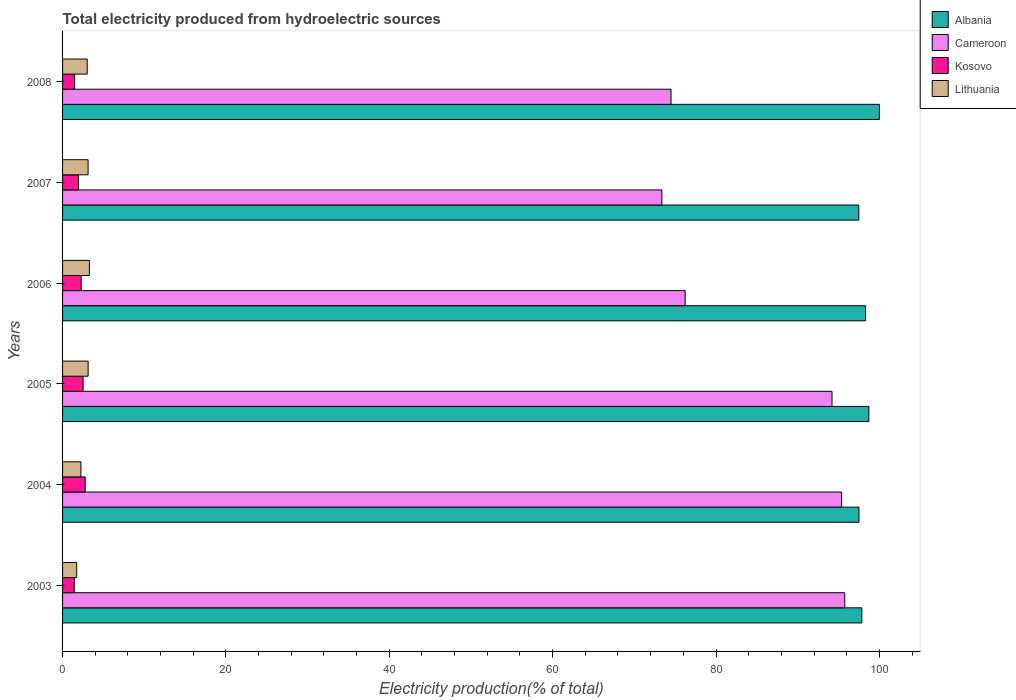How many different coloured bars are there?
Your response must be concise. 4. Are the number of bars per tick equal to the number of legend labels?
Provide a succinct answer. Yes. What is the label of the 1st group of bars from the top?
Ensure brevity in your answer.  2008. In how many cases, is the number of bars for a given year not equal to the number of legend labels?
Offer a terse response. 0. What is the total electricity produced in Lithuania in 2008?
Keep it short and to the point. 3.02. Across all years, what is the maximum total electricity produced in Lithuania?
Offer a very short reply. 3.29. Across all years, what is the minimum total electricity produced in Kosovo?
Your response must be concise. 1.43. In which year was the total electricity produced in Cameroon minimum?
Your response must be concise. 2007. What is the total total electricity produced in Lithuania in the graph?
Provide a short and direct response. 16.53. What is the difference between the total electricity produced in Lithuania in 2003 and that in 2007?
Your response must be concise. -1.4. What is the difference between the total electricity produced in Albania in 2006 and the total electricity produced in Lithuania in 2008?
Provide a succinct answer. 95.3. What is the average total electricity produced in Albania per year?
Provide a short and direct response. 98.31. In the year 2003, what is the difference between the total electricity produced in Kosovo and total electricity produced in Cameroon?
Keep it short and to the point. -94.33. In how many years, is the total electricity produced in Albania greater than 48 %?
Ensure brevity in your answer.  6. What is the ratio of the total electricity produced in Lithuania in 2004 to that in 2008?
Your response must be concise. 0.74. Is the difference between the total electricity produced in Kosovo in 2003 and 2006 greater than the difference between the total electricity produced in Cameroon in 2003 and 2006?
Offer a very short reply. No. What is the difference between the highest and the second highest total electricity produced in Cameroon?
Your response must be concise. 0.39. What is the difference between the highest and the lowest total electricity produced in Kosovo?
Provide a succinct answer. 1.34. In how many years, is the total electricity produced in Kosovo greater than the average total electricity produced in Kosovo taken over all years?
Provide a short and direct response. 3. Is the sum of the total electricity produced in Albania in 2004 and 2005 greater than the maximum total electricity produced in Cameroon across all years?
Provide a short and direct response. Yes. What does the 2nd bar from the top in 2008 represents?
Provide a short and direct response. Kosovo. What does the 2nd bar from the bottom in 2008 represents?
Your response must be concise. Cameroon. How many bars are there?
Make the answer very short. 24. Are all the bars in the graph horizontal?
Your response must be concise. Yes. Where does the legend appear in the graph?
Keep it short and to the point. Top right. How many legend labels are there?
Make the answer very short. 4. How are the legend labels stacked?
Ensure brevity in your answer.  Vertical. What is the title of the graph?
Your response must be concise. Total electricity produced from hydroelectric sources. Does "Central Europe" appear as one of the legend labels in the graph?
Your answer should be compact. No. What is the label or title of the Y-axis?
Provide a short and direct response. Years. What is the Electricity production(% of total) in Albania in 2003?
Provide a succinct answer. 97.86. What is the Electricity production(% of total) of Cameroon in 2003?
Offer a very short reply. 95.77. What is the Electricity production(% of total) in Kosovo in 2003?
Give a very brief answer. 1.43. What is the Electricity production(% of total) in Lithuania in 2003?
Provide a short and direct response. 1.73. What is the Electricity production(% of total) in Albania in 2004?
Your answer should be compact. 97.5. What is the Electricity production(% of total) in Cameroon in 2004?
Keep it short and to the point. 95.38. What is the Electricity production(% of total) of Kosovo in 2004?
Your response must be concise. 2.77. What is the Electricity production(% of total) in Lithuania in 2004?
Ensure brevity in your answer.  2.25. What is the Electricity production(% of total) in Albania in 2005?
Offer a terse response. 98.71. What is the Electricity production(% of total) in Cameroon in 2005?
Your answer should be compact. 94.21. What is the Electricity production(% of total) of Kosovo in 2005?
Offer a terse response. 2.51. What is the Electricity production(% of total) in Lithuania in 2005?
Ensure brevity in your answer.  3.13. What is the Electricity production(% of total) of Albania in 2006?
Your answer should be very brief. 98.32. What is the Electricity production(% of total) of Cameroon in 2006?
Make the answer very short. 76.22. What is the Electricity production(% of total) in Kosovo in 2006?
Keep it short and to the point. 2.28. What is the Electricity production(% of total) in Lithuania in 2006?
Keep it short and to the point. 3.29. What is the Electricity production(% of total) of Albania in 2007?
Provide a short and direct response. 97.48. What is the Electricity production(% of total) in Cameroon in 2007?
Give a very brief answer. 73.37. What is the Electricity production(% of total) of Kosovo in 2007?
Your answer should be compact. 1.94. What is the Electricity production(% of total) in Lithuania in 2007?
Provide a short and direct response. 3.13. What is the Electricity production(% of total) in Albania in 2008?
Make the answer very short. 100. What is the Electricity production(% of total) of Cameroon in 2008?
Offer a terse response. 74.49. What is the Electricity production(% of total) of Kosovo in 2008?
Provide a short and direct response. 1.47. What is the Electricity production(% of total) in Lithuania in 2008?
Offer a terse response. 3.02. Across all years, what is the maximum Electricity production(% of total) in Cameroon?
Make the answer very short. 95.77. Across all years, what is the maximum Electricity production(% of total) in Kosovo?
Ensure brevity in your answer.  2.77. Across all years, what is the maximum Electricity production(% of total) of Lithuania?
Provide a short and direct response. 3.29. Across all years, what is the minimum Electricity production(% of total) in Albania?
Make the answer very short. 97.48. Across all years, what is the minimum Electricity production(% of total) of Cameroon?
Your answer should be very brief. 73.37. Across all years, what is the minimum Electricity production(% of total) of Kosovo?
Your response must be concise. 1.43. Across all years, what is the minimum Electricity production(% of total) in Lithuania?
Your answer should be compact. 1.73. What is the total Electricity production(% of total) of Albania in the graph?
Offer a terse response. 589.87. What is the total Electricity production(% of total) in Cameroon in the graph?
Provide a succinct answer. 509.44. What is the total Electricity production(% of total) of Kosovo in the graph?
Your answer should be very brief. 12.41. What is the total Electricity production(% of total) in Lithuania in the graph?
Your answer should be very brief. 16.53. What is the difference between the Electricity production(% of total) of Albania in 2003 and that in 2004?
Provide a short and direct response. 0.35. What is the difference between the Electricity production(% of total) in Cameroon in 2003 and that in 2004?
Your answer should be very brief. 0.39. What is the difference between the Electricity production(% of total) of Kosovo in 2003 and that in 2004?
Make the answer very short. -1.34. What is the difference between the Electricity production(% of total) in Lithuania in 2003 and that in 2004?
Provide a succinct answer. -0.52. What is the difference between the Electricity production(% of total) in Albania in 2003 and that in 2005?
Provide a succinct answer. -0.86. What is the difference between the Electricity production(% of total) in Cameroon in 2003 and that in 2005?
Your answer should be very brief. 1.56. What is the difference between the Electricity production(% of total) of Kosovo in 2003 and that in 2005?
Provide a short and direct response. -1.08. What is the difference between the Electricity production(% of total) in Lithuania in 2003 and that in 2005?
Your answer should be very brief. -1.4. What is the difference between the Electricity production(% of total) in Albania in 2003 and that in 2006?
Make the answer very short. -0.46. What is the difference between the Electricity production(% of total) in Cameroon in 2003 and that in 2006?
Your answer should be very brief. 19.54. What is the difference between the Electricity production(% of total) in Kosovo in 2003 and that in 2006?
Offer a terse response. -0.85. What is the difference between the Electricity production(% of total) in Lithuania in 2003 and that in 2006?
Provide a short and direct response. -1.56. What is the difference between the Electricity production(% of total) of Albania in 2003 and that in 2007?
Your response must be concise. 0.37. What is the difference between the Electricity production(% of total) of Cameroon in 2003 and that in 2007?
Ensure brevity in your answer.  22.39. What is the difference between the Electricity production(% of total) of Kosovo in 2003 and that in 2007?
Give a very brief answer. -0.51. What is the difference between the Electricity production(% of total) of Lithuania in 2003 and that in 2007?
Your answer should be compact. -1.4. What is the difference between the Electricity production(% of total) in Albania in 2003 and that in 2008?
Offer a terse response. -2.14. What is the difference between the Electricity production(% of total) of Cameroon in 2003 and that in 2008?
Ensure brevity in your answer.  21.27. What is the difference between the Electricity production(% of total) in Kosovo in 2003 and that in 2008?
Your answer should be compact. -0.04. What is the difference between the Electricity production(% of total) of Lithuania in 2003 and that in 2008?
Give a very brief answer. -1.29. What is the difference between the Electricity production(% of total) of Albania in 2004 and that in 2005?
Keep it short and to the point. -1.21. What is the difference between the Electricity production(% of total) of Cameroon in 2004 and that in 2005?
Offer a terse response. 1.17. What is the difference between the Electricity production(% of total) of Kosovo in 2004 and that in 2005?
Make the answer very short. 0.26. What is the difference between the Electricity production(% of total) in Lithuania in 2004 and that in 2005?
Offer a terse response. -0.88. What is the difference between the Electricity production(% of total) in Albania in 2004 and that in 2006?
Ensure brevity in your answer.  -0.81. What is the difference between the Electricity production(% of total) in Cameroon in 2004 and that in 2006?
Your answer should be compact. 19.15. What is the difference between the Electricity production(% of total) of Kosovo in 2004 and that in 2006?
Keep it short and to the point. 0.49. What is the difference between the Electricity production(% of total) of Lithuania in 2004 and that in 2006?
Provide a short and direct response. -1.04. What is the difference between the Electricity production(% of total) in Albania in 2004 and that in 2007?
Provide a succinct answer. 0.02. What is the difference between the Electricity production(% of total) in Cameroon in 2004 and that in 2007?
Keep it short and to the point. 22. What is the difference between the Electricity production(% of total) of Kosovo in 2004 and that in 2007?
Provide a succinct answer. 0.82. What is the difference between the Electricity production(% of total) of Lithuania in 2004 and that in 2007?
Your answer should be very brief. -0.88. What is the difference between the Electricity production(% of total) in Albania in 2004 and that in 2008?
Your response must be concise. -2.5. What is the difference between the Electricity production(% of total) of Cameroon in 2004 and that in 2008?
Offer a terse response. 20.88. What is the difference between the Electricity production(% of total) of Kosovo in 2004 and that in 2008?
Make the answer very short. 1.3. What is the difference between the Electricity production(% of total) of Lithuania in 2004 and that in 2008?
Offer a very short reply. -0.77. What is the difference between the Electricity production(% of total) of Albania in 2005 and that in 2006?
Your answer should be compact. 0.4. What is the difference between the Electricity production(% of total) in Cameroon in 2005 and that in 2006?
Provide a short and direct response. 17.98. What is the difference between the Electricity production(% of total) in Kosovo in 2005 and that in 2006?
Provide a short and direct response. 0.23. What is the difference between the Electricity production(% of total) of Lithuania in 2005 and that in 2006?
Your answer should be compact. -0.16. What is the difference between the Electricity production(% of total) in Albania in 2005 and that in 2007?
Keep it short and to the point. 1.23. What is the difference between the Electricity production(% of total) in Cameroon in 2005 and that in 2007?
Provide a short and direct response. 20.83. What is the difference between the Electricity production(% of total) in Kosovo in 2005 and that in 2007?
Your answer should be compact. 0.57. What is the difference between the Electricity production(% of total) in Lithuania in 2005 and that in 2007?
Give a very brief answer. 0. What is the difference between the Electricity production(% of total) of Albania in 2005 and that in 2008?
Provide a short and direct response. -1.29. What is the difference between the Electricity production(% of total) in Cameroon in 2005 and that in 2008?
Ensure brevity in your answer.  19.71. What is the difference between the Electricity production(% of total) of Kosovo in 2005 and that in 2008?
Provide a short and direct response. 1.04. What is the difference between the Electricity production(% of total) in Lithuania in 2005 and that in 2008?
Offer a very short reply. 0.11. What is the difference between the Electricity production(% of total) in Albania in 2006 and that in 2007?
Keep it short and to the point. 0.83. What is the difference between the Electricity production(% of total) in Cameroon in 2006 and that in 2007?
Your answer should be very brief. 2.85. What is the difference between the Electricity production(% of total) in Kosovo in 2006 and that in 2007?
Your answer should be very brief. 0.33. What is the difference between the Electricity production(% of total) in Lithuania in 2006 and that in 2007?
Keep it short and to the point. 0.16. What is the difference between the Electricity production(% of total) in Albania in 2006 and that in 2008?
Make the answer very short. -1.68. What is the difference between the Electricity production(% of total) of Cameroon in 2006 and that in 2008?
Provide a succinct answer. 1.73. What is the difference between the Electricity production(% of total) in Kosovo in 2006 and that in 2008?
Make the answer very short. 0.81. What is the difference between the Electricity production(% of total) of Lithuania in 2006 and that in 2008?
Give a very brief answer. 0.27. What is the difference between the Electricity production(% of total) of Albania in 2007 and that in 2008?
Provide a short and direct response. -2.52. What is the difference between the Electricity production(% of total) in Cameroon in 2007 and that in 2008?
Provide a succinct answer. -1.12. What is the difference between the Electricity production(% of total) of Kosovo in 2007 and that in 2008?
Your response must be concise. 0.47. What is the difference between the Electricity production(% of total) of Lithuania in 2007 and that in 2008?
Your answer should be very brief. 0.11. What is the difference between the Electricity production(% of total) in Albania in 2003 and the Electricity production(% of total) in Cameroon in 2004?
Your answer should be compact. 2.48. What is the difference between the Electricity production(% of total) of Albania in 2003 and the Electricity production(% of total) of Kosovo in 2004?
Provide a succinct answer. 95.09. What is the difference between the Electricity production(% of total) of Albania in 2003 and the Electricity production(% of total) of Lithuania in 2004?
Provide a succinct answer. 95.61. What is the difference between the Electricity production(% of total) in Cameroon in 2003 and the Electricity production(% of total) in Kosovo in 2004?
Ensure brevity in your answer.  93. What is the difference between the Electricity production(% of total) in Cameroon in 2003 and the Electricity production(% of total) in Lithuania in 2004?
Offer a very short reply. 93.52. What is the difference between the Electricity production(% of total) in Kosovo in 2003 and the Electricity production(% of total) in Lithuania in 2004?
Ensure brevity in your answer.  -0.81. What is the difference between the Electricity production(% of total) in Albania in 2003 and the Electricity production(% of total) in Cameroon in 2005?
Provide a succinct answer. 3.65. What is the difference between the Electricity production(% of total) in Albania in 2003 and the Electricity production(% of total) in Kosovo in 2005?
Keep it short and to the point. 95.34. What is the difference between the Electricity production(% of total) of Albania in 2003 and the Electricity production(% of total) of Lithuania in 2005?
Provide a succinct answer. 94.73. What is the difference between the Electricity production(% of total) in Cameroon in 2003 and the Electricity production(% of total) in Kosovo in 2005?
Give a very brief answer. 93.25. What is the difference between the Electricity production(% of total) of Cameroon in 2003 and the Electricity production(% of total) of Lithuania in 2005?
Keep it short and to the point. 92.64. What is the difference between the Electricity production(% of total) in Kosovo in 2003 and the Electricity production(% of total) in Lithuania in 2005?
Your response must be concise. -1.7. What is the difference between the Electricity production(% of total) in Albania in 2003 and the Electricity production(% of total) in Cameroon in 2006?
Ensure brevity in your answer.  21.63. What is the difference between the Electricity production(% of total) of Albania in 2003 and the Electricity production(% of total) of Kosovo in 2006?
Your answer should be very brief. 95.58. What is the difference between the Electricity production(% of total) of Albania in 2003 and the Electricity production(% of total) of Lithuania in 2006?
Provide a succinct answer. 94.57. What is the difference between the Electricity production(% of total) of Cameroon in 2003 and the Electricity production(% of total) of Kosovo in 2006?
Offer a terse response. 93.49. What is the difference between the Electricity production(% of total) in Cameroon in 2003 and the Electricity production(% of total) in Lithuania in 2006?
Your answer should be compact. 92.48. What is the difference between the Electricity production(% of total) in Kosovo in 2003 and the Electricity production(% of total) in Lithuania in 2006?
Your response must be concise. -1.85. What is the difference between the Electricity production(% of total) in Albania in 2003 and the Electricity production(% of total) in Cameroon in 2007?
Your answer should be very brief. 24.48. What is the difference between the Electricity production(% of total) in Albania in 2003 and the Electricity production(% of total) in Kosovo in 2007?
Ensure brevity in your answer.  95.91. What is the difference between the Electricity production(% of total) of Albania in 2003 and the Electricity production(% of total) of Lithuania in 2007?
Give a very brief answer. 94.73. What is the difference between the Electricity production(% of total) of Cameroon in 2003 and the Electricity production(% of total) of Kosovo in 2007?
Offer a terse response. 93.82. What is the difference between the Electricity production(% of total) of Cameroon in 2003 and the Electricity production(% of total) of Lithuania in 2007?
Offer a terse response. 92.64. What is the difference between the Electricity production(% of total) of Kosovo in 2003 and the Electricity production(% of total) of Lithuania in 2007?
Make the answer very short. -1.69. What is the difference between the Electricity production(% of total) in Albania in 2003 and the Electricity production(% of total) in Cameroon in 2008?
Your answer should be compact. 23.36. What is the difference between the Electricity production(% of total) of Albania in 2003 and the Electricity production(% of total) of Kosovo in 2008?
Ensure brevity in your answer.  96.38. What is the difference between the Electricity production(% of total) of Albania in 2003 and the Electricity production(% of total) of Lithuania in 2008?
Make the answer very short. 94.84. What is the difference between the Electricity production(% of total) of Cameroon in 2003 and the Electricity production(% of total) of Kosovo in 2008?
Provide a short and direct response. 94.29. What is the difference between the Electricity production(% of total) of Cameroon in 2003 and the Electricity production(% of total) of Lithuania in 2008?
Offer a very short reply. 92.75. What is the difference between the Electricity production(% of total) in Kosovo in 2003 and the Electricity production(% of total) in Lithuania in 2008?
Your answer should be compact. -1.58. What is the difference between the Electricity production(% of total) of Albania in 2004 and the Electricity production(% of total) of Cameroon in 2005?
Keep it short and to the point. 3.3. What is the difference between the Electricity production(% of total) of Albania in 2004 and the Electricity production(% of total) of Kosovo in 2005?
Provide a succinct answer. 94.99. What is the difference between the Electricity production(% of total) in Albania in 2004 and the Electricity production(% of total) in Lithuania in 2005?
Your response must be concise. 94.37. What is the difference between the Electricity production(% of total) in Cameroon in 2004 and the Electricity production(% of total) in Kosovo in 2005?
Give a very brief answer. 92.86. What is the difference between the Electricity production(% of total) in Cameroon in 2004 and the Electricity production(% of total) in Lithuania in 2005?
Ensure brevity in your answer.  92.25. What is the difference between the Electricity production(% of total) in Kosovo in 2004 and the Electricity production(% of total) in Lithuania in 2005?
Provide a short and direct response. -0.36. What is the difference between the Electricity production(% of total) in Albania in 2004 and the Electricity production(% of total) in Cameroon in 2006?
Offer a very short reply. 21.28. What is the difference between the Electricity production(% of total) of Albania in 2004 and the Electricity production(% of total) of Kosovo in 2006?
Your answer should be very brief. 95.22. What is the difference between the Electricity production(% of total) in Albania in 2004 and the Electricity production(% of total) in Lithuania in 2006?
Provide a succinct answer. 94.22. What is the difference between the Electricity production(% of total) in Cameroon in 2004 and the Electricity production(% of total) in Kosovo in 2006?
Offer a very short reply. 93.1. What is the difference between the Electricity production(% of total) of Cameroon in 2004 and the Electricity production(% of total) of Lithuania in 2006?
Give a very brief answer. 92.09. What is the difference between the Electricity production(% of total) of Kosovo in 2004 and the Electricity production(% of total) of Lithuania in 2006?
Provide a short and direct response. -0.52. What is the difference between the Electricity production(% of total) in Albania in 2004 and the Electricity production(% of total) in Cameroon in 2007?
Make the answer very short. 24.13. What is the difference between the Electricity production(% of total) in Albania in 2004 and the Electricity production(% of total) in Kosovo in 2007?
Offer a terse response. 95.56. What is the difference between the Electricity production(% of total) in Albania in 2004 and the Electricity production(% of total) in Lithuania in 2007?
Your response must be concise. 94.38. What is the difference between the Electricity production(% of total) in Cameroon in 2004 and the Electricity production(% of total) in Kosovo in 2007?
Offer a terse response. 93.43. What is the difference between the Electricity production(% of total) in Cameroon in 2004 and the Electricity production(% of total) in Lithuania in 2007?
Keep it short and to the point. 92.25. What is the difference between the Electricity production(% of total) in Kosovo in 2004 and the Electricity production(% of total) in Lithuania in 2007?
Make the answer very short. -0.36. What is the difference between the Electricity production(% of total) of Albania in 2004 and the Electricity production(% of total) of Cameroon in 2008?
Provide a succinct answer. 23.01. What is the difference between the Electricity production(% of total) of Albania in 2004 and the Electricity production(% of total) of Kosovo in 2008?
Keep it short and to the point. 96.03. What is the difference between the Electricity production(% of total) of Albania in 2004 and the Electricity production(% of total) of Lithuania in 2008?
Offer a very short reply. 94.49. What is the difference between the Electricity production(% of total) of Cameroon in 2004 and the Electricity production(% of total) of Kosovo in 2008?
Your answer should be very brief. 93.9. What is the difference between the Electricity production(% of total) in Cameroon in 2004 and the Electricity production(% of total) in Lithuania in 2008?
Your answer should be compact. 92.36. What is the difference between the Electricity production(% of total) in Kosovo in 2004 and the Electricity production(% of total) in Lithuania in 2008?
Offer a terse response. -0.25. What is the difference between the Electricity production(% of total) of Albania in 2005 and the Electricity production(% of total) of Cameroon in 2006?
Provide a succinct answer. 22.49. What is the difference between the Electricity production(% of total) in Albania in 2005 and the Electricity production(% of total) in Kosovo in 2006?
Your answer should be very brief. 96.44. What is the difference between the Electricity production(% of total) of Albania in 2005 and the Electricity production(% of total) of Lithuania in 2006?
Provide a short and direct response. 95.43. What is the difference between the Electricity production(% of total) of Cameroon in 2005 and the Electricity production(% of total) of Kosovo in 2006?
Ensure brevity in your answer.  91.93. What is the difference between the Electricity production(% of total) of Cameroon in 2005 and the Electricity production(% of total) of Lithuania in 2006?
Your answer should be very brief. 90.92. What is the difference between the Electricity production(% of total) in Kosovo in 2005 and the Electricity production(% of total) in Lithuania in 2006?
Your response must be concise. -0.77. What is the difference between the Electricity production(% of total) of Albania in 2005 and the Electricity production(% of total) of Cameroon in 2007?
Make the answer very short. 25.34. What is the difference between the Electricity production(% of total) in Albania in 2005 and the Electricity production(% of total) in Kosovo in 2007?
Make the answer very short. 96.77. What is the difference between the Electricity production(% of total) in Albania in 2005 and the Electricity production(% of total) in Lithuania in 2007?
Your response must be concise. 95.59. What is the difference between the Electricity production(% of total) of Cameroon in 2005 and the Electricity production(% of total) of Kosovo in 2007?
Keep it short and to the point. 92.26. What is the difference between the Electricity production(% of total) of Cameroon in 2005 and the Electricity production(% of total) of Lithuania in 2007?
Your response must be concise. 91.08. What is the difference between the Electricity production(% of total) of Kosovo in 2005 and the Electricity production(% of total) of Lithuania in 2007?
Make the answer very short. -0.61. What is the difference between the Electricity production(% of total) of Albania in 2005 and the Electricity production(% of total) of Cameroon in 2008?
Offer a terse response. 24.22. What is the difference between the Electricity production(% of total) of Albania in 2005 and the Electricity production(% of total) of Kosovo in 2008?
Provide a short and direct response. 97.24. What is the difference between the Electricity production(% of total) in Albania in 2005 and the Electricity production(% of total) in Lithuania in 2008?
Offer a very short reply. 95.7. What is the difference between the Electricity production(% of total) of Cameroon in 2005 and the Electricity production(% of total) of Kosovo in 2008?
Provide a short and direct response. 92.73. What is the difference between the Electricity production(% of total) of Cameroon in 2005 and the Electricity production(% of total) of Lithuania in 2008?
Keep it short and to the point. 91.19. What is the difference between the Electricity production(% of total) in Kosovo in 2005 and the Electricity production(% of total) in Lithuania in 2008?
Your answer should be compact. -0.5. What is the difference between the Electricity production(% of total) of Albania in 2006 and the Electricity production(% of total) of Cameroon in 2007?
Make the answer very short. 24.94. What is the difference between the Electricity production(% of total) of Albania in 2006 and the Electricity production(% of total) of Kosovo in 2007?
Your answer should be very brief. 96.37. What is the difference between the Electricity production(% of total) of Albania in 2006 and the Electricity production(% of total) of Lithuania in 2007?
Ensure brevity in your answer.  95.19. What is the difference between the Electricity production(% of total) of Cameroon in 2006 and the Electricity production(% of total) of Kosovo in 2007?
Provide a short and direct response. 74.28. What is the difference between the Electricity production(% of total) of Cameroon in 2006 and the Electricity production(% of total) of Lithuania in 2007?
Keep it short and to the point. 73.1. What is the difference between the Electricity production(% of total) in Kosovo in 2006 and the Electricity production(% of total) in Lithuania in 2007?
Your response must be concise. -0.85. What is the difference between the Electricity production(% of total) in Albania in 2006 and the Electricity production(% of total) in Cameroon in 2008?
Offer a very short reply. 23.82. What is the difference between the Electricity production(% of total) of Albania in 2006 and the Electricity production(% of total) of Kosovo in 2008?
Offer a very short reply. 96.84. What is the difference between the Electricity production(% of total) of Albania in 2006 and the Electricity production(% of total) of Lithuania in 2008?
Your answer should be compact. 95.3. What is the difference between the Electricity production(% of total) of Cameroon in 2006 and the Electricity production(% of total) of Kosovo in 2008?
Your response must be concise. 74.75. What is the difference between the Electricity production(% of total) of Cameroon in 2006 and the Electricity production(% of total) of Lithuania in 2008?
Provide a succinct answer. 73.21. What is the difference between the Electricity production(% of total) of Kosovo in 2006 and the Electricity production(% of total) of Lithuania in 2008?
Your answer should be compact. -0.74. What is the difference between the Electricity production(% of total) in Albania in 2007 and the Electricity production(% of total) in Cameroon in 2008?
Your answer should be very brief. 22.99. What is the difference between the Electricity production(% of total) of Albania in 2007 and the Electricity production(% of total) of Kosovo in 2008?
Give a very brief answer. 96.01. What is the difference between the Electricity production(% of total) of Albania in 2007 and the Electricity production(% of total) of Lithuania in 2008?
Your answer should be very brief. 94.47. What is the difference between the Electricity production(% of total) in Cameroon in 2007 and the Electricity production(% of total) in Kosovo in 2008?
Offer a very short reply. 71.9. What is the difference between the Electricity production(% of total) in Cameroon in 2007 and the Electricity production(% of total) in Lithuania in 2008?
Give a very brief answer. 70.36. What is the difference between the Electricity production(% of total) in Kosovo in 2007 and the Electricity production(% of total) in Lithuania in 2008?
Make the answer very short. -1.07. What is the average Electricity production(% of total) in Albania per year?
Keep it short and to the point. 98.31. What is the average Electricity production(% of total) in Cameroon per year?
Offer a very short reply. 84.91. What is the average Electricity production(% of total) of Kosovo per year?
Provide a succinct answer. 2.07. What is the average Electricity production(% of total) of Lithuania per year?
Provide a succinct answer. 2.75. In the year 2003, what is the difference between the Electricity production(% of total) of Albania and Electricity production(% of total) of Cameroon?
Provide a succinct answer. 2.09. In the year 2003, what is the difference between the Electricity production(% of total) in Albania and Electricity production(% of total) in Kosovo?
Offer a very short reply. 96.42. In the year 2003, what is the difference between the Electricity production(% of total) in Albania and Electricity production(% of total) in Lithuania?
Your response must be concise. 96.13. In the year 2003, what is the difference between the Electricity production(% of total) of Cameroon and Electricity production(% of total) of Kosovo?
Make the answer very short. 94.33. In the year 2003, what is the difference between the Electricity production(% of total) of Cameroon and Electricity production(% of total) of Lithuania?
Make the answer very short. 94.04. In the year 2003, what is the difference between the Electricity production(% of total) of Kosovo and Electricity production(% of total) of Lithuania?
Offer a terse response. -0.29. In the year 2004, what is the difference between the Electricity production(% of total) in Albania and Electricity production(% of total) in Cameroon?
Make the answer very short. 2.13. In the year 2004, what is the difference between the Electricity production(% of total) of Albania and Electricity production(% of total) of Kosovo?
Your response must be concise. 94.73. In the year 2004, what is the difference between the Electricity production(% of total) of Albania and Electricity production(% of total) of Lithuania?
Offer a very short reply. 95.26. In the year 2004, what is the difference between the Electricity production(% of total) in Cameroon and Electricity production(% of total) in Kosovo?
Keep it short and to the point. 92.61. In the year 2004, what is the difference between the Electricity production(% of total) in Cameroon and Electricity production(% of total) in Lithuania?
Make the answer very short. 93.13. In the year 2004, what is the difference between the Electricity production(% of total) of Kosovo and Electricity production(% of total) of Lithuania?
Ensure brevity in your answer.  0.52. In the year 2005, what is the difference between the Electricity production(% of total) in Albania and Electricity production(% of total) in Cameroon?
Your answer should be compact. 4.51. In the year 2005, what is the difference between the Electricity production(% of total) in Albania and Electricity production(% of total) in Kosovo?
Provide a succinct answer. 96.2. In the year 2005, what is the difference between the Electricity production(% of total) in Albania and Electricity production(% of total) in Lithuania?
Your response must be concise. 95.59. In the year 2005, what is the difference between the Electricity production(% of total) of Cameroon and Electricity production(% of total) of Kosovo?
Make the answer very short. 91.69. In the year 2005, what is the difference between the Electricity production(% of total) of Cameroon and Electricity production(% of total) of Lithuania?
Ensure brevity in your answer.  91.08. In the year 2005, what is the difference between the Electricity production(% of total) in Kosovo and Electricity production(% of total) in Lithuania?
Make the answer very short. -0.62. In the year 2006, what is the difference between the Electricity production(% of total) of Albania and Electricity production(% of total) of Cameroon?
Give a very brief answer. 22.09. In the year 2006, what is the difference between the Electricity production(% of total) of Albania and Electricity production(% of total) of Kosovo?
Provide a short and direct response. 96.04. In the year 2006, what is the difference between the Electricity production(% of total) in Albania and Electricity production(% of total) in Lithuania?
Your answer should be compact. 95.03. In the year 2006, what is the difference between the Electricity production(% of total) of Cameroon and Electricity production(% of total) of Kosovo?
Ensure brevity in your answer.  73.95. In the year 2006, what is the difference between the Electricity production(% of total) of Cameroon and Electricity production(% of total) of Lithuania?
Your answer should be compact. 72.94. In the year 2006, what is the difference between the Electricity production(% of total) of Kosovo and Electricity production(% of total) of Lithuania?
Give a very brief answer. -1.01. In the year 2007, what is the difference between the Electricity production(% of total) in Albania and Electricity production(% of total) in Cameroon?
Your response must be concise. 24.11. In the year 2007, what is the difference between the Electricity production(% of total) of Albania and Electricity production(% of total) of Kosovo?
Keep it short and to the point. 95.54. In the year 2007, what is the difference between the Electricity production(% of total) in Albania and Electricity production(% of total) in Lithuania?
Ensure brevity in your answer.  94.36. In the year 2007, what is the difference between the Electricity production(% of total) of Cameroon and Electricity production(% of total) of Kosovo?
Offer a very short reply. 71.43. In the year 2007, what is the difference between the Electricity production(% of total) in Cameroon and Electricity production(% of total) in Lithuania?
Your answer should be very brief. 70.25. In the year 2007, what is the difference between the Electricity production(% of total) of Kosovo and Electricity production(% of total) of Lithuania?
Offer a terse response. -1.18. In the year 2008, what is the difference between the Electricity production(% of total) in Albania and Electricity production(% of total) in Cameroon?
Keep it short and to the point. 25.51. In the year 2008, what is the difference between the Electricity production(% of total) in Albania and Electricity production(% of total) in Kosovo?
Offer a terse response. 98.53. In the year 2008, what is the difference between the Electricity production(% of total) in Albania and Electricity production(% of total) in Lithuania?
Provide a short and direct response. 96.98. In the year 2008, what is the difference between the Electricity production(% of total) of Cameroon and Electricity production(% of total) of Kosovo?
Your answer should be compact. 73.02. In the year 2008, what is the difference between the Electricity production(% of total) in Cameroon and Electricity production(% of total) in Lithuania?
Offer a terse response. 71.48. In the year 2008, what is the difference between the Electricity production(% of total) of Kosovo and Electricity production(% of total) of Lithuania?
Offer a very short reply. -1.54. What is the ratio of the Electricity production(% of total) in Albania in 2003 to that in 2004?
Your answer should be very brief. 1. What is the ratio of the Electricity production(% of total) of Cameroon in 2003 to that in 2004?
Give a very brief answer. 1. What is the ratio of the Electricity production(% of total) of Kosovo in 2003 to that in 2004?
Your response must be concise. 0.52. What is the ratio of the Electricity production(% of total) in Lithuania in 2003 to that in 2004?
Provide a succinct answer. 0.77. What is the ratio of the Electricity production(% of total) in Albania in 2003 to that in 2005?
Keep it short and to the point. 0.99. What is the ratio of the Electricity production(% of total) in Cameroon in 2003 to that in 2005?
Ensure brevity in your answer.  1.02. What is the ratio of the Electricity production(% of total) of Kosovo in 2003 to that in 2005?
Offer a terse response. 0.57. What is the ratio of the Electricity production(% of total) in Lithuania in 2003 to that in 2005?
Make the answer very short. 0.55. What is the ratio of the Electricity production(% of total) of Albania in 2003 to that in 2006?
Your response must be concise. 1. What is the ratio of the Electricity production(% of total) of Cameroon in 2003 to that in 2006?
Offer a very short reply. 1.26. What is the ratio of the Electricity production(% of total) in Kosovo in 2003 to that in 2006?
Make the answer very short. 0.63. What is the ratio of the Electricity production(% of total) in Lithuania in 2003 to that in 2006?
Your answer should be compact. 0.53. What is the ratio of the Electricity production(% of total) in Cameroon in 2003 to that in 2007?
Provide a short and direct response. 1.31. What is the ratio of the Electricity production(% of total) of Kosovo in 2003 to that in 2007?
Keep it short and to the point. 0.74. What is the ratio of the Electricity production(% of total) of Lithuania in 2003 to that in 2007?
Your answer should be very brief. 0.55. What is the ratio of the Electricity production(% of total) in Albania in 2003 to that in 2008?
Your response must be concise. 0.98. What is the ratio of the Electricity production(% of total) of Cameroon in 2003 to that in 2008?
Ensure brevity in your answer.  1.29. What is the ratio of the Electricity production(% of total) of Kosovo in 2003 to that in 2008?
Offer a very short reply. 0.97. What is the ratio of the Electricity production(% of total) of Lithuania in 2003 to that in 2008?
Make the answer very short. 0.57. What is the ratio of the Electricity production(% of total) in Albania in 2004 to that in 2005?
Your answer should be very brief. 0.99. What is the ratio of the Electricity production(% of total) in Cameroon in 2004 to that in 2005?
Your response must be concise. 1.01. What is the ratio of the Electricity production(% of total) of Kosovo in 2004 to that in 2005?
Your response must be concise. 1.1. What is the ratio of the Electricity production(% of total) in Lithuania in 2004 to that in 2005?
Provide a short and direct response. 0.72. What is the ratio of the Electricity production(% of total) of Cameroon in 2004 to that in 2006?
Offer a terse response. 1.25. What is the ratio of the Electricity production(% of total) in Kosovo in 2004 to that in 2006?
Make the answer very short. 1.22. What is the ratio of the Electricity production(% of total) in Lithuania in 2004 to that in 2006?
Make the answer very short. 0.68. What is the ratio of the Electricity production(% of total) of Albania in 2004 to that in 2007?
Give a very brief answer. 1. What is the ratio of the Electricity production(% of total) of Cameroon in 2004 to that in 2007?
Keep it short and to the point. 1.3. What is the ratio of the Electricity production(% of total) in Kosovo in 2004 to that in 2007?
Make the answer very short. 1.42. What is the ratio of the Electricity production(% of total) of Lithuania in 2004 to that in 2007?
Ensure brevity in your answer.  0.72. What is the ratio of the Electricity production(% of total) of Albania in 2004 to that in 2008?
Give a very brief answer. 0.97. What is the ratio of the Electricity production(% of total) of Cameroon in 2004 to that in 2008?
Keep it short and to the point. 1.28. What is the ratio of the Electricity production(% of total) in Kosovo in 2004 to that in 2008?
Make the answer very short. 1.88. What is the ratio of the Electricity production(% of total) in Lithuania in 2004 to that in 2008?
Your response must be concise. 0.74. What is the ratio of the Electricity production(% of total) in Albania in 2005 to that in 2006?
Provide a succinct answer. 1. What is the ratio of the Electricity production(% of total) of Cameroon in 2005 to that in 2006?
Your answer should be compact. 1.24. What is the ratio of the Electricity production(% of total) in Kosovo in 2005 to that in 2006?
Ensure brevity in your answer.  1.1. What is the ratio of the Electricity production(% of total) in Lithuania in 2005 to that in 2006?
Ensure brevity in your answer.  0.95. What is the ratio of the Electricity production(% of total) of Albania in 2005 to that in 2007?
Offer a terse response. 1.01. What is the ratio of the Electricity production(% of total) of Cameroon in 2005 to that in 2007?
Provide a succinct answer. 1.28. What is the ratio of the Electricity production(% of total) of Kosovo in 2005 to that in 2007?
Keep it short and to the point. 1.29. What is the ratio of the Electricity production(% of total) of Albania in 2005 to that in 2008?
Your answer should be compact. 0.99. What is the ratio of the Electricity production(% of total) of Cameroon in 2005 to that in 2008?
Provide a short and direct response. 1.26. What is the ratio of the Electricity production(% of total) of Kosovo in 2005 to that in 2008?
Your answer should be very brief. 1.71. What is the ratio of the Electricity production(% of total) of Lithuania in 2005 to that in 2008?
Your answer should be compact. 1.04. What is the ratio of the Electricity production(% of total) in Albania in 2006 to that in 2007?
Your response must be concise. 1.01. What is the ratio of the Electricity production(% of total) of Cameroon in 2006 to that in 2007?
Provide a succinct answer. 1.04. What is the ratio of the Electricity production(% of total) of Kosovo in 2006 to that in 2007?
Offer a very short reply. 1.17. What is the ratio of the Electricity production(% of total) of Lithuania in 2006 to that in 2007?
Your answer should be very brief. 1.05. What is the ratio of the Electricity production(% of total) of Albania in 2006 to that in 2008?
Provide a succinct answer. 0.98. What is the ratio of the Electricity production(% of total) of Cameroon in 2006 to that in 2008?
Your answer should be compact. 1.02. What is the ratio of the Electricity production(% of total) of Kosovo in 2006 to that in 2008?
Your response must be concise. 1.55. What is the ratio of the Electricity production(% of total) in Lithuania in 2006 to that in 2008?
Provide a succinct answer. 1.09. What is the ratio of the Electricity production(% of total) of Albania in 2007 to that in 2008?
Offer a very short reply. 0.97. What is the ratio of the Electricity production(% of total) in Cameroon in 2007 to that in 2008?
Provide a succinct answer. 0.98. What is the ratio of the Electricity production(% of total) in Kosovo in 2007 to that in 2008?
Ensure brevity in your answer.  1.32. What is the ratio of the Electricity production(% of total) in Lithuania in 2007 to that in 2008?
Offer a terse response. 1.04. What is the difference between the highest and the second highest Electricity production(% of total) in Albania?
Offer a terse response. 1.29. What is the difference between the highest and the second highest Electricity production(% of total) in Cameroon?
Your answer should be compact. 0.39. What is the difference between the highest and the second highest Electricity production(% of total) in Kosovo?
Offer a very short reply. 0.26. What is the difference between the highest and the second highest Electricity production(% of total) of Lithuania?
Your answer should be very brief. 0.16. What is the difference between the highest and the lowest Electricity production(% of total) in Albania?
Your answer should be very brief. 2.52. What is the difference between the highest and the lowest Electricity production(% of total) in Cameroon?
Provide a succinct answer. 22.39. What is the difference between the highest and the lowest Electricity production(% of total) in Kosovo?
Make the answer very short. 1.34. What is the difference between the highest and the lowest Electricity production(% of total) of Lithuania?
Ensure brevity in your answer.  1.56. 